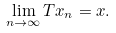<formula> <loc_0><loc_0><loc_500><loc_500>\lim _ { n \to \infty } T x _ { n } = x .</formula> 